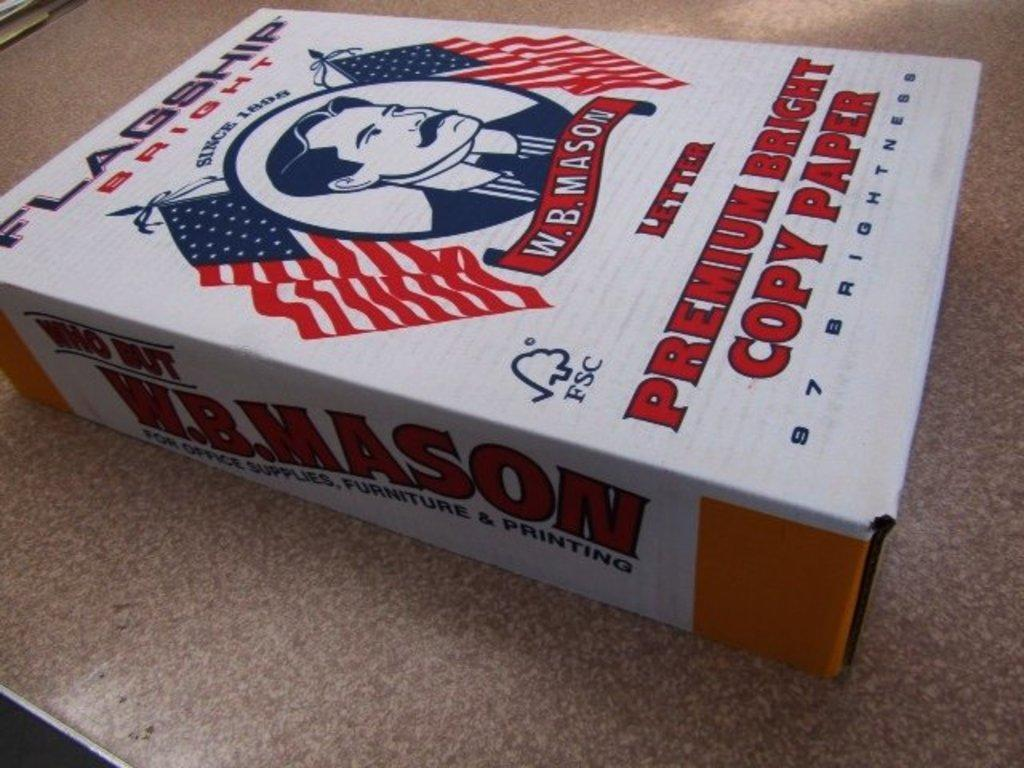What object is located on the table in the image? There is a cardboard box on the table in the image. What is the cardboard box used for? The cardboard box is likely used for packaging or storage, as it has text and images visible on it. Can you describe the text on the cardboard box? Unfortunately, the specific text on the cardboard box cannot be determined from the image. Can you describe the images on the cardboard box? Unfortunately, the specific images on the cardboard box cannot be determined from the image. How many squirrels are sitting on the edge of the cardboard box in the image? There are no squirrels visible in the image; it only features a cardboard box on a table. 